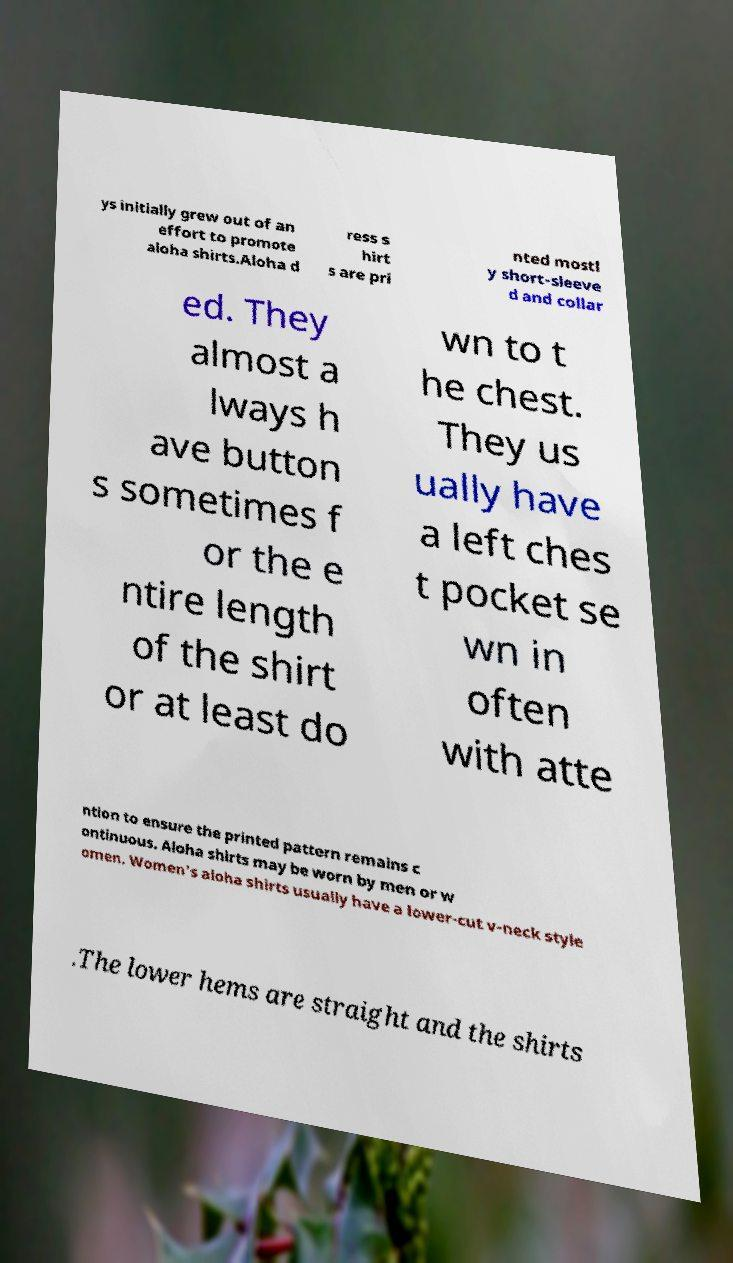Could you assist in decoding the text presented in this image and type it out clearly? ys initially grew out of an effort to promote aloha shirts.Aloha d ress s hirt s are pri nted mostl y short-sleeve d and collar ed. They almost a lways h ave button s sometimes f or the e ntire length of the shirt or at least do wn to t he chest. They us ually have a left ches t pocket se wn in often with atte ntion to ensure the printed pattern remains c ontinuous. Aloha shirts may be worn by men or w omen. Women's aloha shirts usually have a lower-cut v-neck style .The lower hems are straight and the shirts 